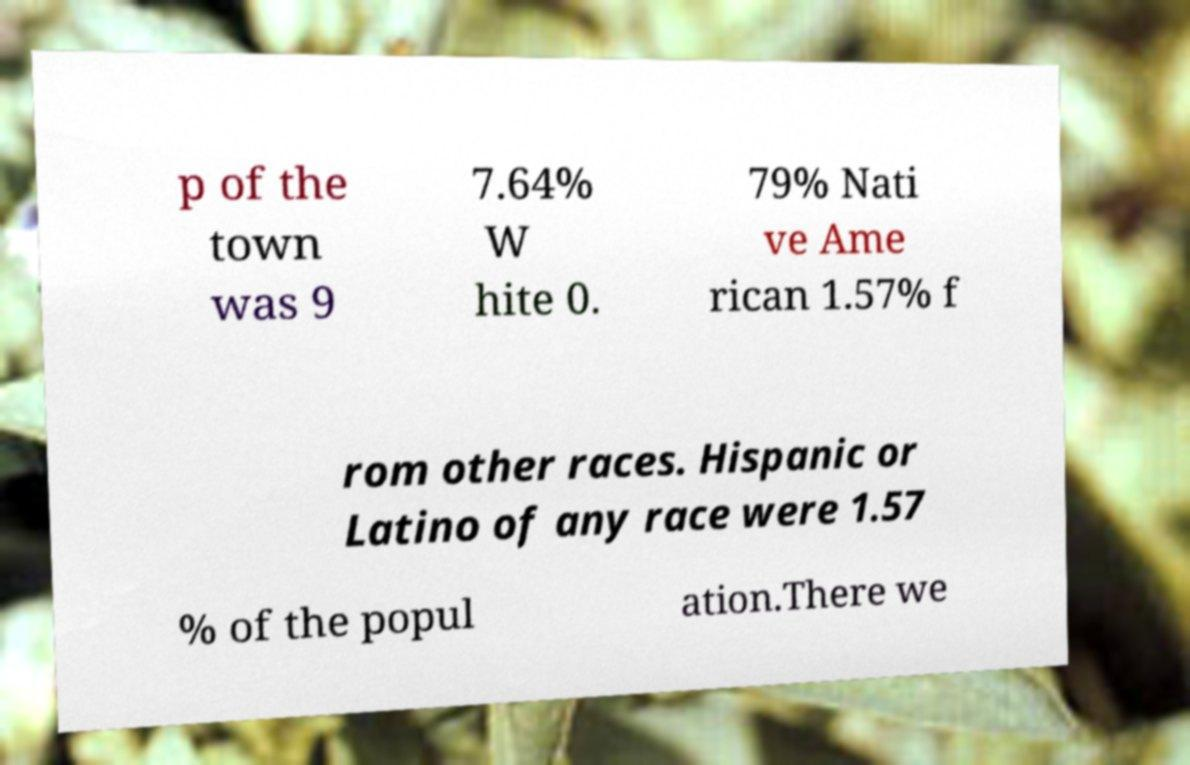There's text embedded in this image that I need extracted. Can you transcribe it verbatim? p of the town was 9 7.64% W hite 0. 79% Nati ve Ame rican 1.57% f rom other races. Hispanic or Latino of any race were 1.57 % of the popul ation.There we 